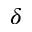Convert formula to latex. <formula><loc_0><loc_0><loc_500><loc_500>\delta</formula> 